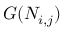Convert formula to latex. <formula><loc_0><loc_0><loc_500><loc_500>G ( N _ { i , j } )</formula> 